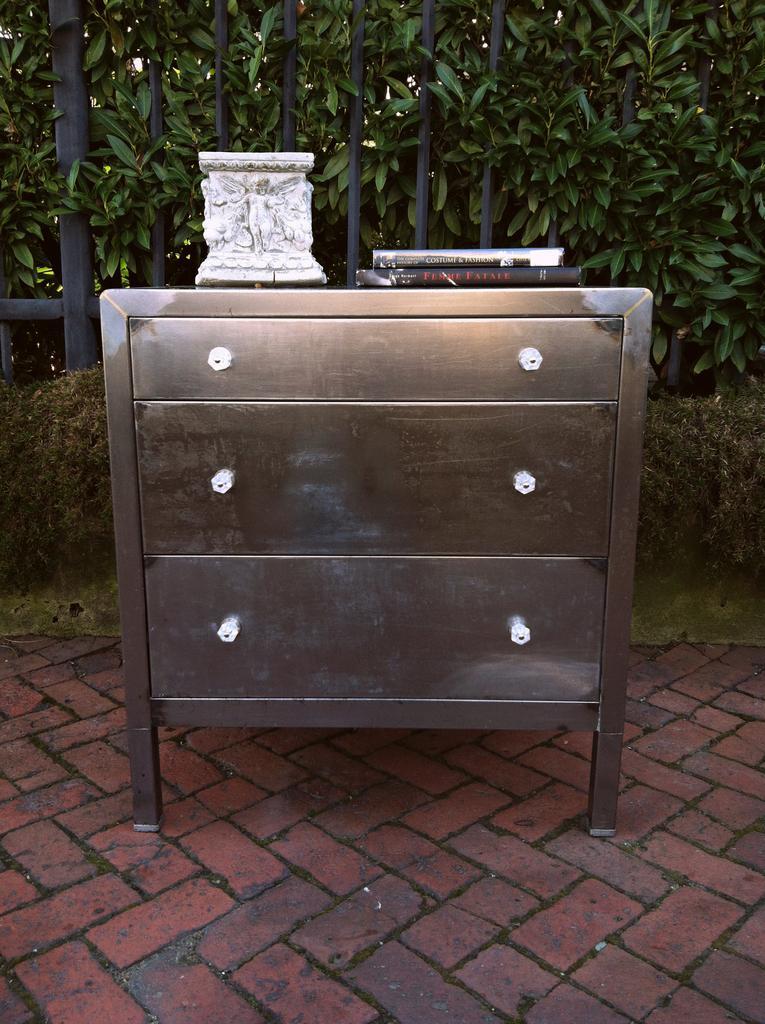Describe this image in one or two sentences. In the image in the center, we can see one table and drawers. On the table, we can see one sculpture and books. In the background there is a wall, fence and plants. 